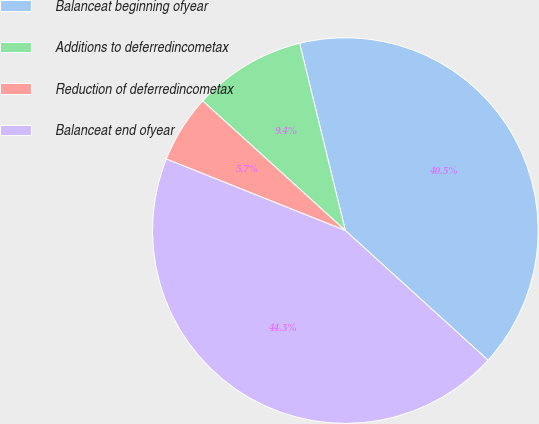Convert chart. <chart><loc_0><loc_0><loc_500><loc_500><pie_chart><fcel>Balanceat beginning ofyear<fcel>Additions to deferredincometax<fcel>Reduction of deferredincometax<fcel>Balanceat end ofyear<nl><fcel>40.55%<fcel>9.45%<fcel>5.69%<fcel>44.31%<nl></chart> 